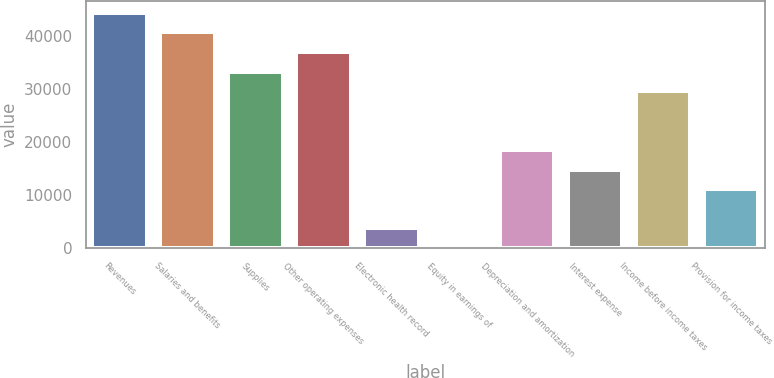<chart> <loc_0><loc_0><loc_500><loc_500><bar_chart><fcel>Revenues<fcel>Salaries and benefits<fcel>Supplies<fcel>Other operating expenses<fcel>Electronic health record<fcel>Equity in earnings of<fcel>Depreciation and amortization<fcel>Interest expense<fcel>Income before income taxes<fcel>Provision for income taxes<nl><fcel>44293<fcel>40605.5<fcel>33230.5<fcel>36918<fcel>3730.5<fcel>43<fcel>18480.5<fcel>14793<fcel>29543<fcel>11105.5<nl></chart> 